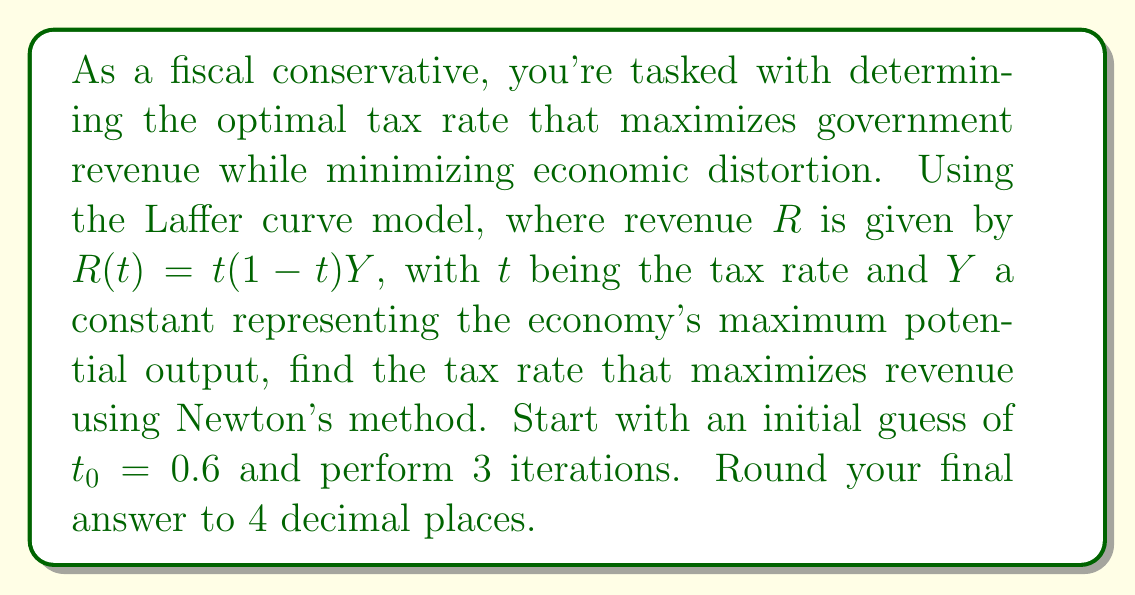Give your solution to this math problem. To solve this problem using Newton's method, we follow these steps:

1) The objective function is $R(t) = t(1-t)Y$. We need to maximize this function.

2) To find the maximum, we need to find where $R'(t) = 0$. The derivative is:
   $R'(t) = (1-2t)Y$

3) Newton's method formula: $t_{n+1} = t_n - \frac{f(t_n)}{f'(t_n)}$

   Where $f(t) = R'(t) = (1-2t)Y$ and $f'(t) = -2Y$

4) Substituting into Newton's method:
   $t_{n+1} = t_n - \frac{(1-2t_n)Y}{-2Y} = t_n + \frac{1-2t_n}{2}$

5) Iterate 3 times starting with $t_0 = 0.6$:

   $t_1 = 0.6 + \frac{1-2(0.6)}{2} = 0.6 + \frac{-0.2}{2} = 0.5$

   $t_2 = 0.5 + \frac{1-2(0.5)}{2} = 0.5 + 0 = 0.5$

   $t_3 = 0.5 + \frac{1-2(0.5)}{2} = 0.5 + 0 = 0.5$

6) The optimal tax rate converges to 0.5 or 50%.
Answer: 0.5000 